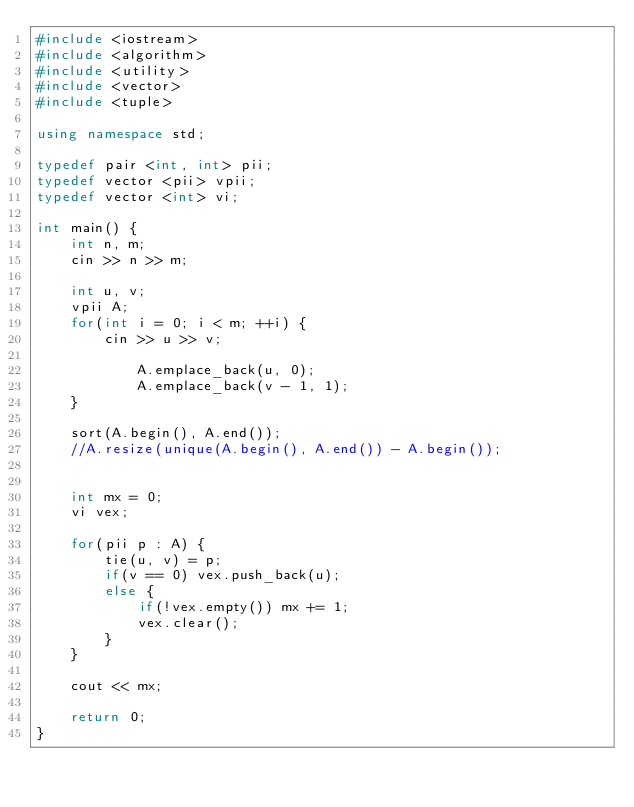Convert code to text. <code><loc_0><loc_0><loc_500><loc_500><_C++_>#include <iostream>
#include <algorithm>
#include <utility>
#include <vector>
#include <tuple>

using namespace std;

typedef pair <int, int> pii;
typedef vector <pii> vpii;
typedef vector <int> vi;

int main() {
    int n, m;
    cin >> n >> m;
    
    int u, v;
    vpii A;
    for(int i = 0; i < m; ++i) {
        cin >> u >> v;

            A.emplace_back(u, 0);
            A.emplace_back(v - 1, 1);
    }
    
    sort(A.begin(), A.end());
    //A.resize(unique(A.begin(), A.end()) - A.begin());
    
    
    int mx = 0;
    vi vex;
    
    for(pii p : A) {
        tie(u, v) = p;
        if(v == 0) vex.push_back(u);
        else {
            if(!vex.empty()) mx += 1;
            vex.clear();
        }
    }
    
    cout << mx;
    
    return 0;
}</code> 